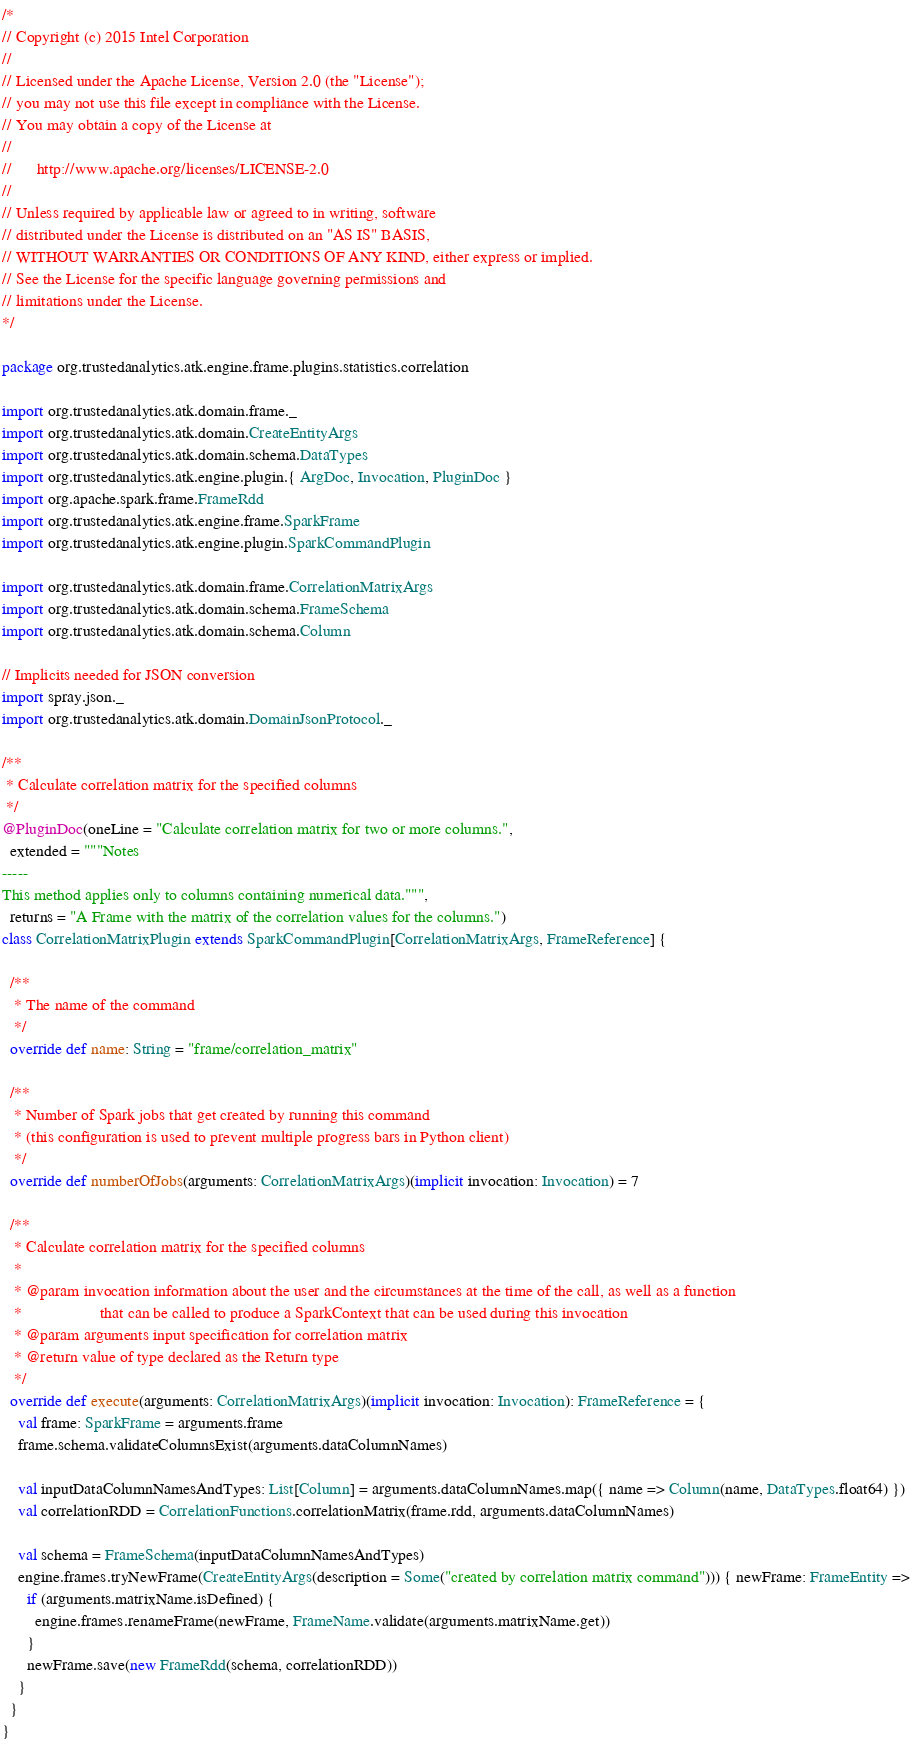Convert code to text. <code><loc_0><loc_0><loc_500><loc_500><_Scala_>/*
// Copyright (c) 2015 Intel Corporation 
//
// Licensed under the Apache License, Version 2.0 (the "License");
// you may not use this file except in compliance with the License.
// You may obtain a copy of the License at
//
//      http://www.apache.org/licenses/LICENSE-2.0
//
// Unless required by applicable law or agreed to in writing, software
// distributed under the License is distributed on an "AS IS" BASIS,
// WITHOUT WARRANTIES OR CONDITIONS OF ANY KIND, either express or implied.
// See the License for the specific language governing permissions and
// limitations under the License.
*/

package org.trustedanalytics.atk.engine.frame.plugins.statistics.correlation

import org.trustedanalytics.atk.domain.frame._
import org.trustedanalytics.atk.domain.CreateEntityArgs
import org.trustedanalytics.atk.domain.schema.DataTypes
import org.trustedanalytics.atk.engine.plugin.{ ArgDoc, Invocation, PluginDoc }
import org.apache.spark.frame.FrameRdd
import org.trustedanalytics.atk.engine.frame.SparkFrame
import org.trustedanalytics.atk.engine.plugin.SparkCommandPlugin

import org.trustedanalytics.atk.domain.frame.CorrelationMatrixArgs
import org.trustedanalytics.atk.domain.schema.FrameSchema
import org.trustedanalytics.atk.domain.schema.Column

// Implicits needed for JSON conversion
import spray.json._
import org.trustedanalytics.atk.domain.DomainJsonProtocol._

/**
 * Calculate correlation matrix for the specified columns
 */
@PluginDoc(oneLine = "Calculate correlation matrix for two or more columns.",
  extended = """Notes
-----
This method applies only to columns containing numerical data.""",
  returns = "A Frame with the matrix of the correlation values for the columns.")
class CorrelationMatrixPlugin extends SparkCommandPlugin[CorrelationMatrixArgs, FrameReference] {

  /**
   * The name of the command
   */
  override def name: String = "frame/correlation_matrix"

  /**
   * Number of Spark jobs that get created by running this command
   * (this configuration is used to prevent multiple progress bars in Python client)
   */
  override def numberOfJobs(arguments: CorrelationMatrixArgs)(implicit invocation: Invocation) = 7

  /**
   * Calculate correlation matrix for the specified columns
   *
   * @param invocation information about the user and the circumstances at the time of the call, as well as a function
   *                   that can be called to produce a SparkContext that can be used during this invocation
   * @param arguments input specification for correlation matrix
   * @return value of type declared as the Return type
   */
  override def execute(arguments: CorrelationMatrixArgs)(implicit invocation: Invocation): FrameReference = {
    val frame: SparkFrame = arguments.frame
    frame.schema.validateColumnsExist(arguments.dataColumnNames)

    val inputDataColumnNamesAndTypes: List[Column] = arguments.dataColumnNames.map({ name => Column(name, DataTypes.float64) })
    val correlationRDD = CorrelationFunctions.correlationMatrix(frame.rdd, arguments.dataColumnNames)

    val schema = FrameSchema(inputDataColumnNamesAndTypes)
    engine.frames.tryNewFrame(CreateEntityArgs(description = Some("created by correlation matrix command"))) { newFrame: FrameEntity =>
      if (arguments.matrixName.isDefined) {
        engine.frames.renameFrame(newFrame, FrameName.validate(arguments.matrixName.get))
      }
      newFrame.save(new FrameRdd(schema, correlationRDD))
    }
  }
}
</code> 